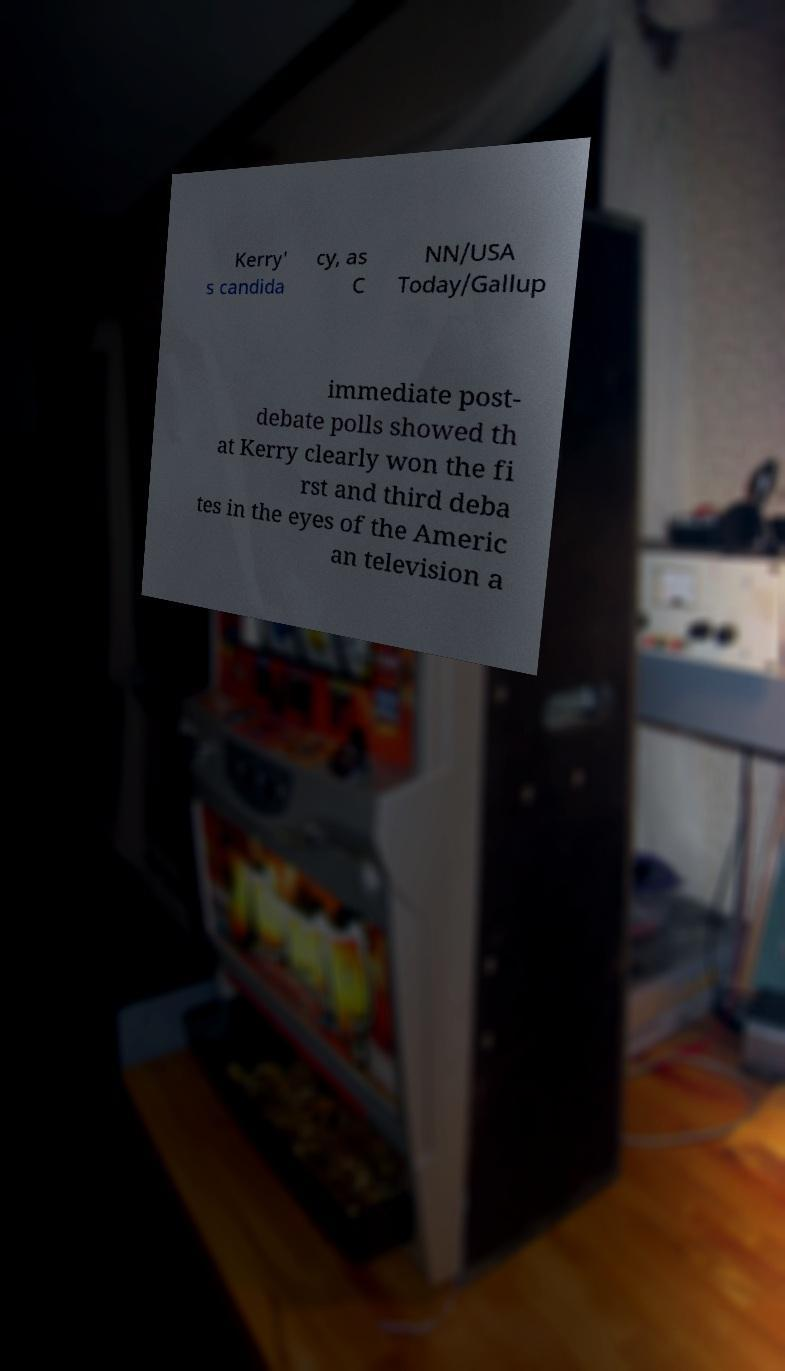Could you assist in decoding the text presented in this image and type it out clearly? Kerry' s candida cy, as C NN/USA Today/Gallup immediate post- debate polls showed th at Kerry clearly won the fi rst and third deba tes in the eyes of the Americ an television a 